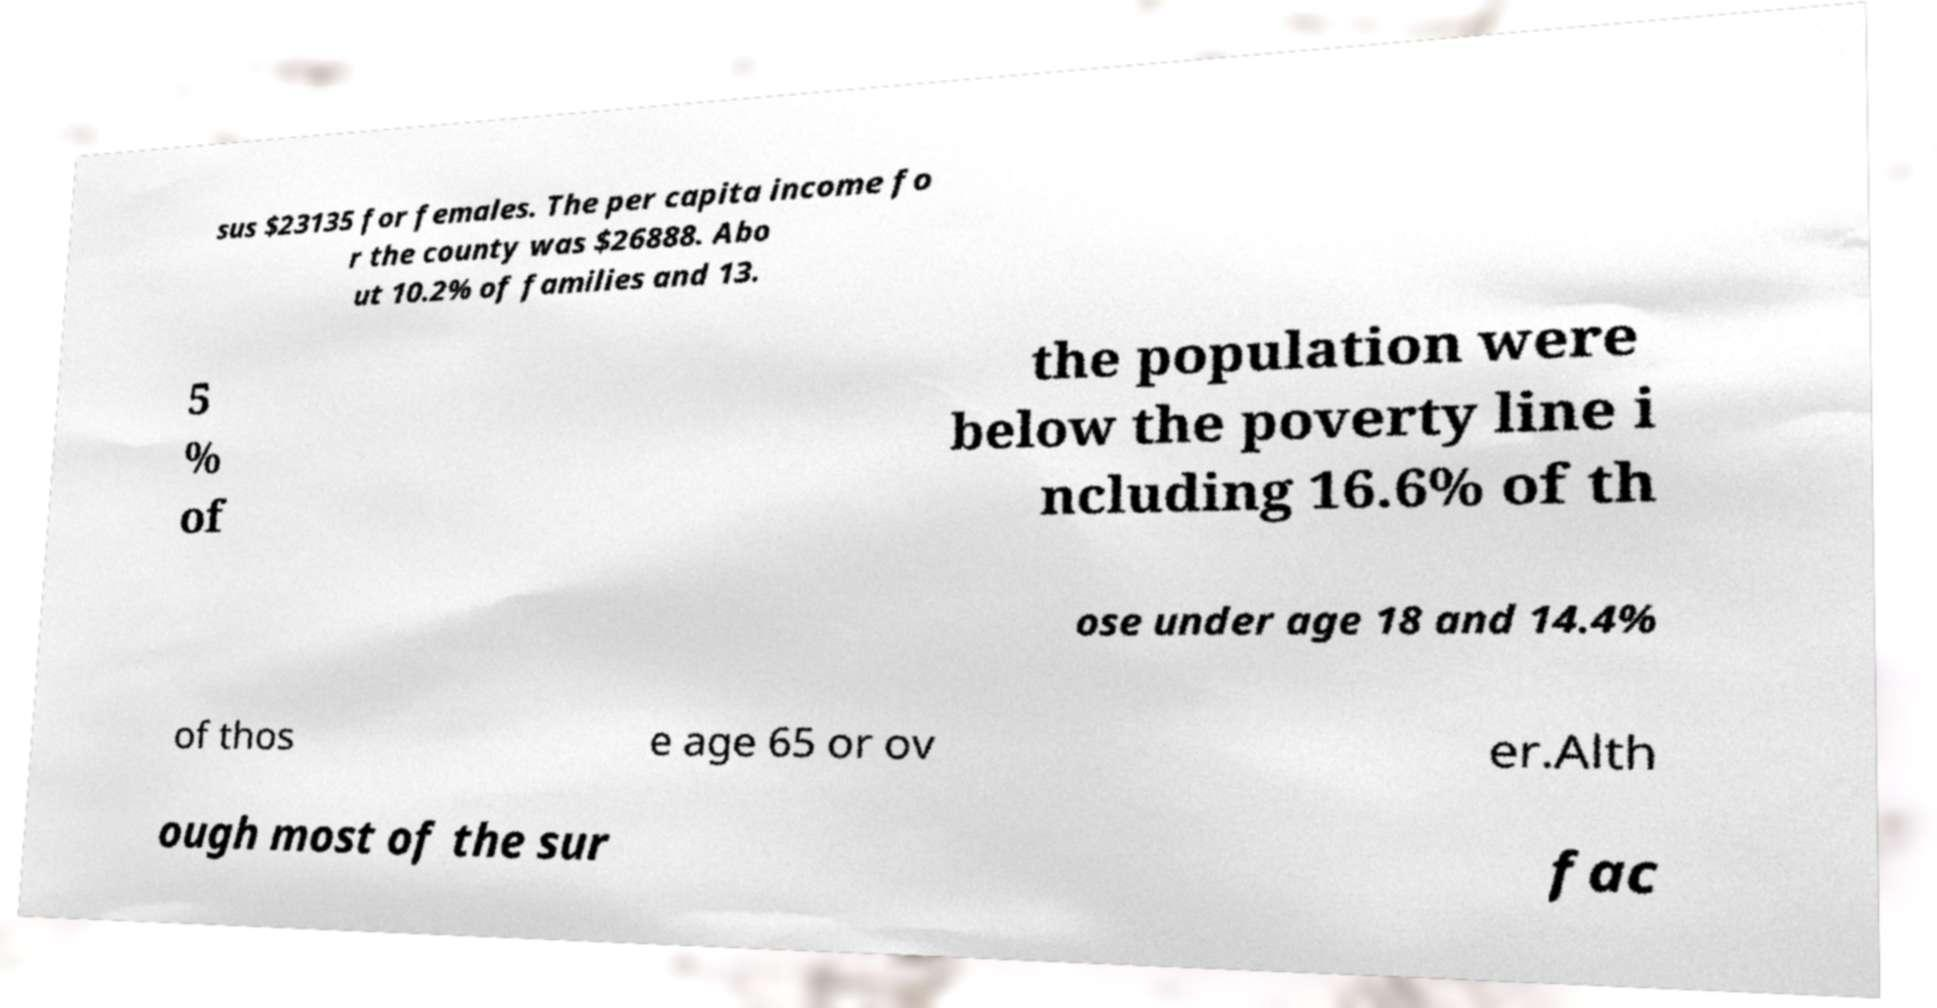I need the written content from this picture converted into text. Can you do that? sus $23135 for females. The per capita income fo r the county was $26888. Abo ut 10.2% of families and 13. 5 % of the population were below the poverty line i ncluding 16.6% of th ose under age 18 and 14.4% of thos e age 65 or ov er.Alth ough most of the sur fac 